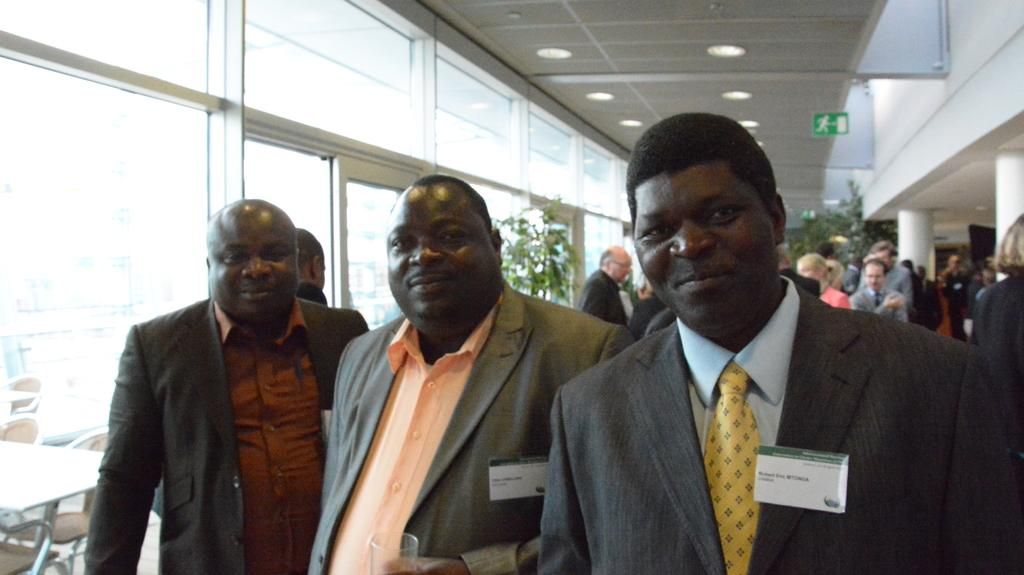Who or what is present in the image? There are people in the image. What is the background of the image? There is a wall in the image. What can be seen illuminating the scene? There are lights in the image. What architectural features are visible in the image? There are windows in the image. What type of vegetation is present in the image? There are plants in the image. What type of art is being performed on stage in the image? There is no stage or art performance present in the image. 